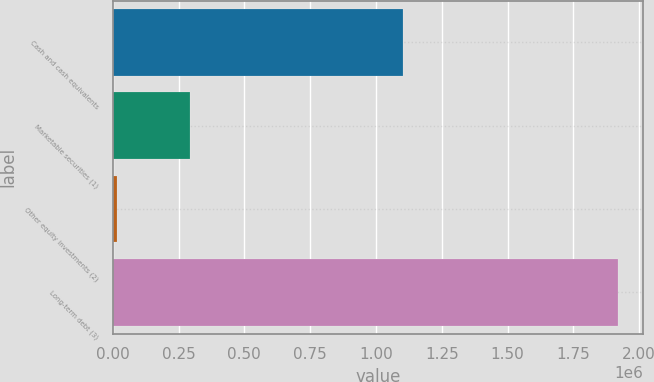Convert chart. <chart><loc_0><loc_0><loc_500><loc_500><bar_chart><fcel>Cash and cash equivalents<fcel>Marketable securities (1)<fcel>Other equity investments (2)<fcel>Long-term debt (3)<nl><fcel>1.10227e+06<fcel>292550<fcel>14831<fcel>1.91947e+06<nl></chart> 